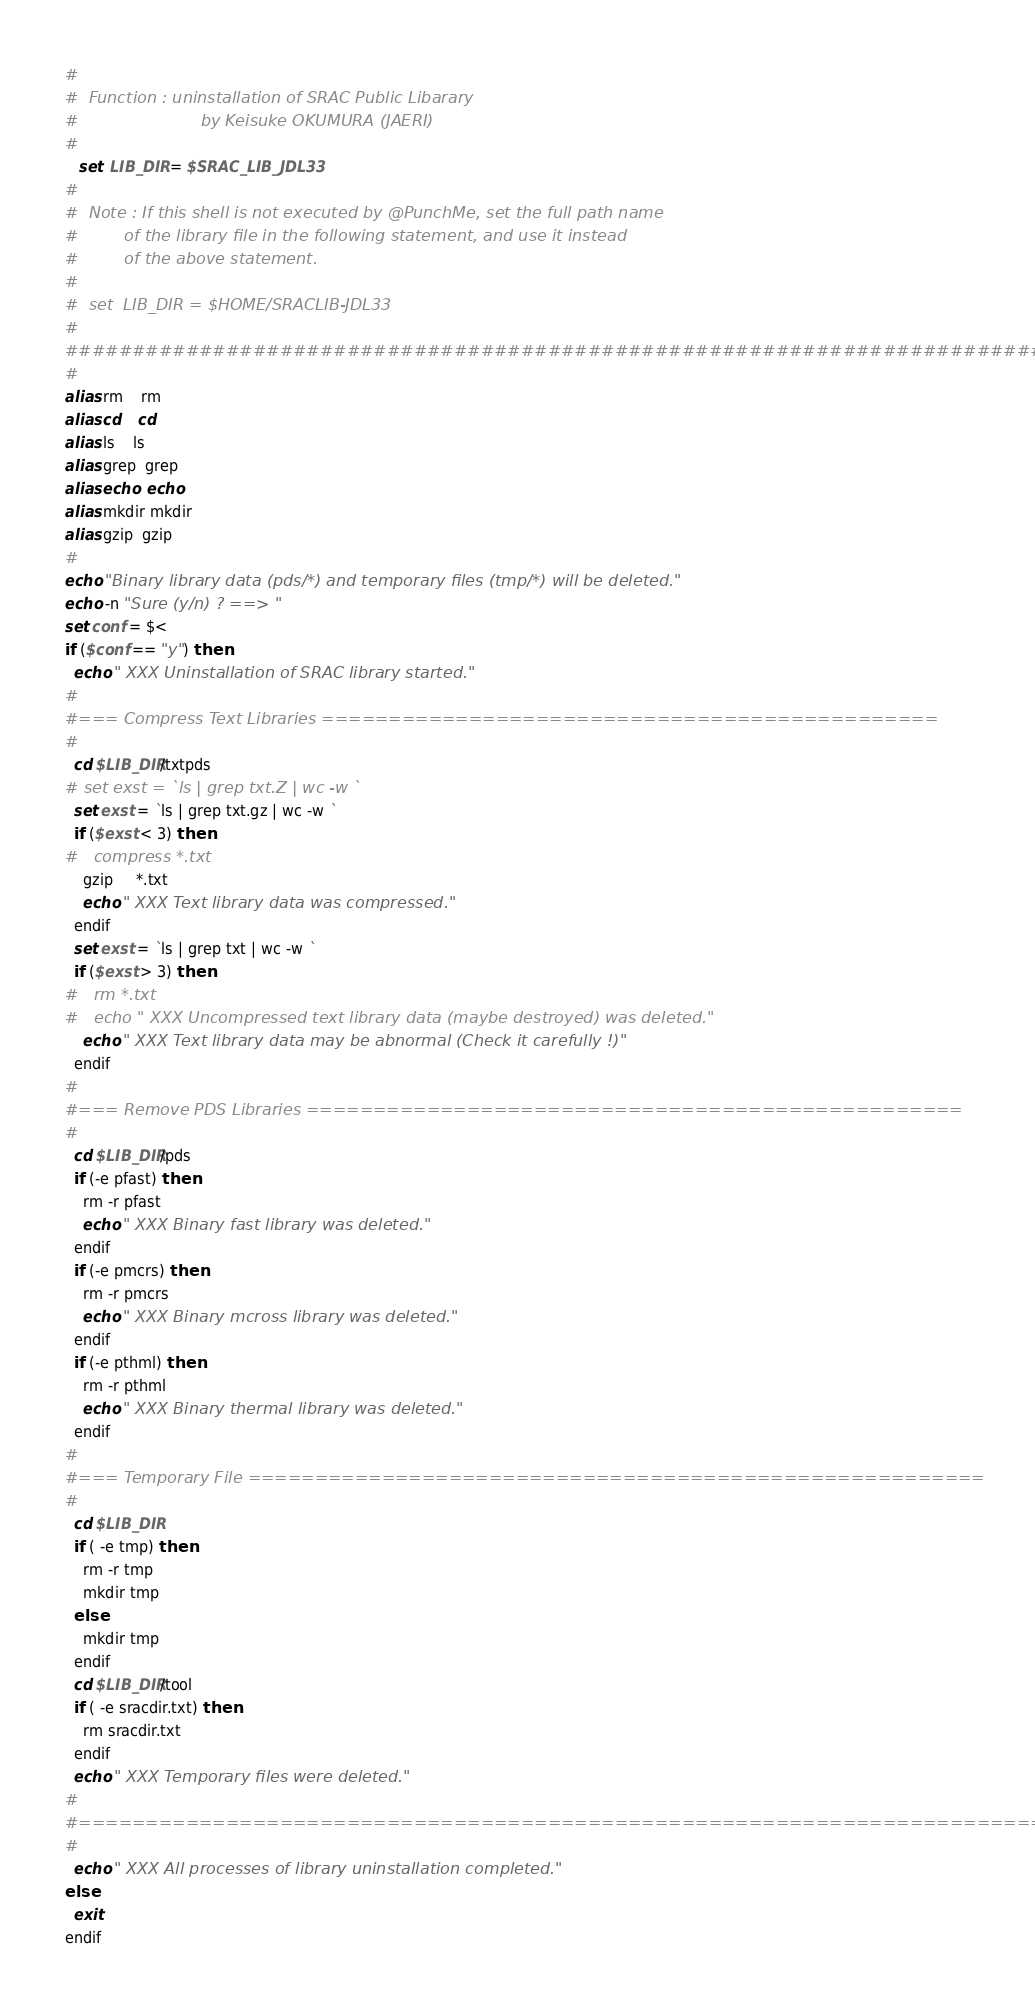Convert code to text. <code><loc_0><loc_0><loc_500><loc_500><_Bash_>#                                                                       
#  Function : uninstallation of SRAC Public Libarary
#                        by Keisuke OKUMURA (JAERI)
#
   set  LIB_DIR = $SRAC_LIB_JDL33
#
#  Note : If this shell is not executed by @PunchMe, set the full path name
#         of the library file in the following statement, and use it instead 
#         of the above statement.
#
#  set  LIB_DIR = $HOME/SRACLIB-JDL33
#                                                                       
###########################################################################
#
alias rm    rm
alias cd    cd
alias ls    ls
alias grep  grep
alias echo  echo
alias mkdir mkdir
alias gzip  gzip
#
echo "Binary library data (pds/*) and temporary files (tmp/*) will be deleted."
echo -n "Sure (y/n) ? ==> "
set conf = $<
if ($conf == "y") then
  echo " XXX Uninstallation of SRAC library started."
#
#=== Compress Text Libraries ==============================================
#
  cd $LIB_DIR/txtpds
# set exst = `ls | grep txt.Z | wc -w `
  set exst = `ls | grep txt.gz | wc -w `
  if ($exst < 3) then
#   compress *.txt
    gzip     *.txt
    echo " XXX Text library data was compressed."
  endif
  set exst = `ls | grep txt | wc -w `
  if ($exst > 3) then
#   rm *.txt
#   echo " XXX Uncompressed text library data (maybe destroyed) was deleted."
    echo " XXX Text library data may be abnormal (Check it carefully !)"
  endif
#
#=== Remove PDS Libraries =================================================
#
  cd $LIB_DIR/pds
  if (-e pfast) then
    rm -r pfast
    echo " XXX Binary fast library was deleted."
  endif
  if (-e pmcrs) then
    rm -r pmcrs
    echo " XXX Binary mcross library was deleted."
  endif
  if (-e pthml) then
    rm -r pthml
    echo " XXX Binary thermal library was deleted."
  endif
#
#=== Temporary File =======================================================
#
  cd $LIB_DIR
  if ( -e tmp) then
    rm -r tmp
    mkdir tmp
  else
    mkdir tmp
  endif
  cd $LIB_DIR/tool
  if ( -e sracdir.txt) then
    rm sracdir.txt
  endif
  echo " XXX Temporary files were deleted."
#
#==========================================================================
#
  echo " XXX All processes of library uninstallation completed."
else   
  exit
endif
</code> 